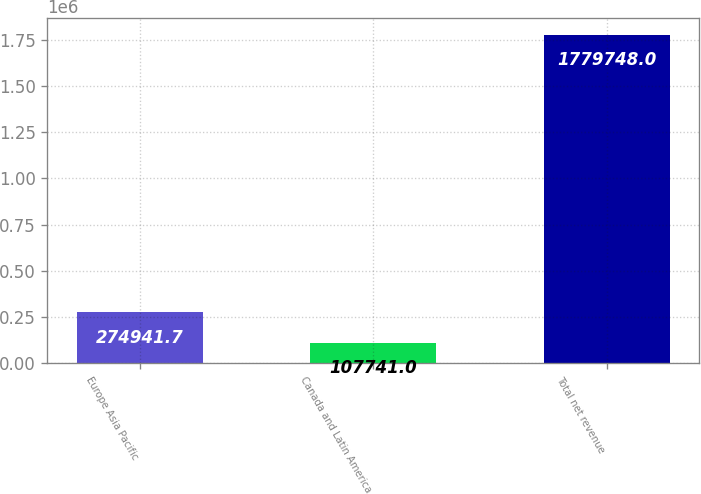Convert chart. <chart><loc_0><loc_0><loc_500><loc_500><bar_chart><fcel>Europe Asia Pacific<fcel>Canada and Latin America<fcel>Total net revenue<nl><fcel>274942<fcel>107741<fcel>1.77975e+06<nl></chart> 